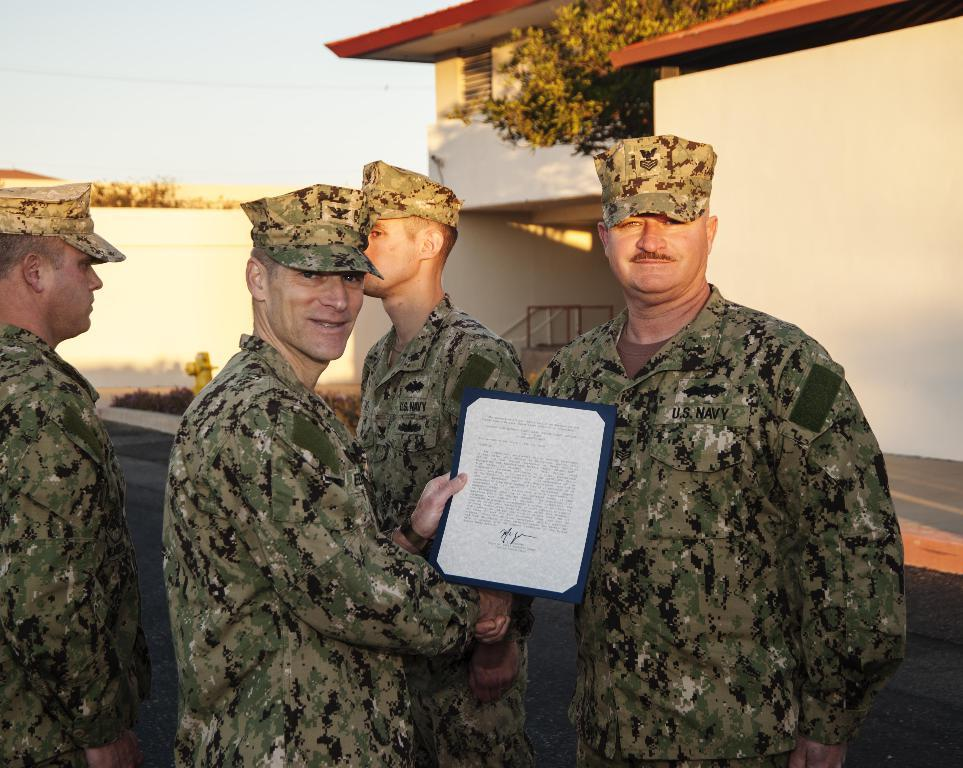What type of people can be seen in the image? There are army people in the image. Where are the army people located in relation to the house? The army people are standing in front of a house. What action are two persons performing in the image? Two persons are shaking hands. What object is being held by one person in the image? One person is holding a paper. What type of vegetable is being used as a decoration on the shelf in the image? There is no shelf or vegetable present in the image. Can you tell me how many ducks are visible in the image? There are no ducks present in the image. 